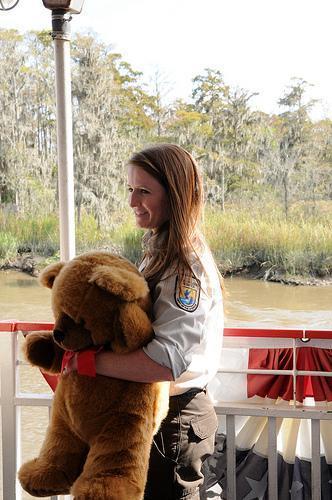How many stuffed crocodiles are in the picture?
Give a very brief answer. 0. 